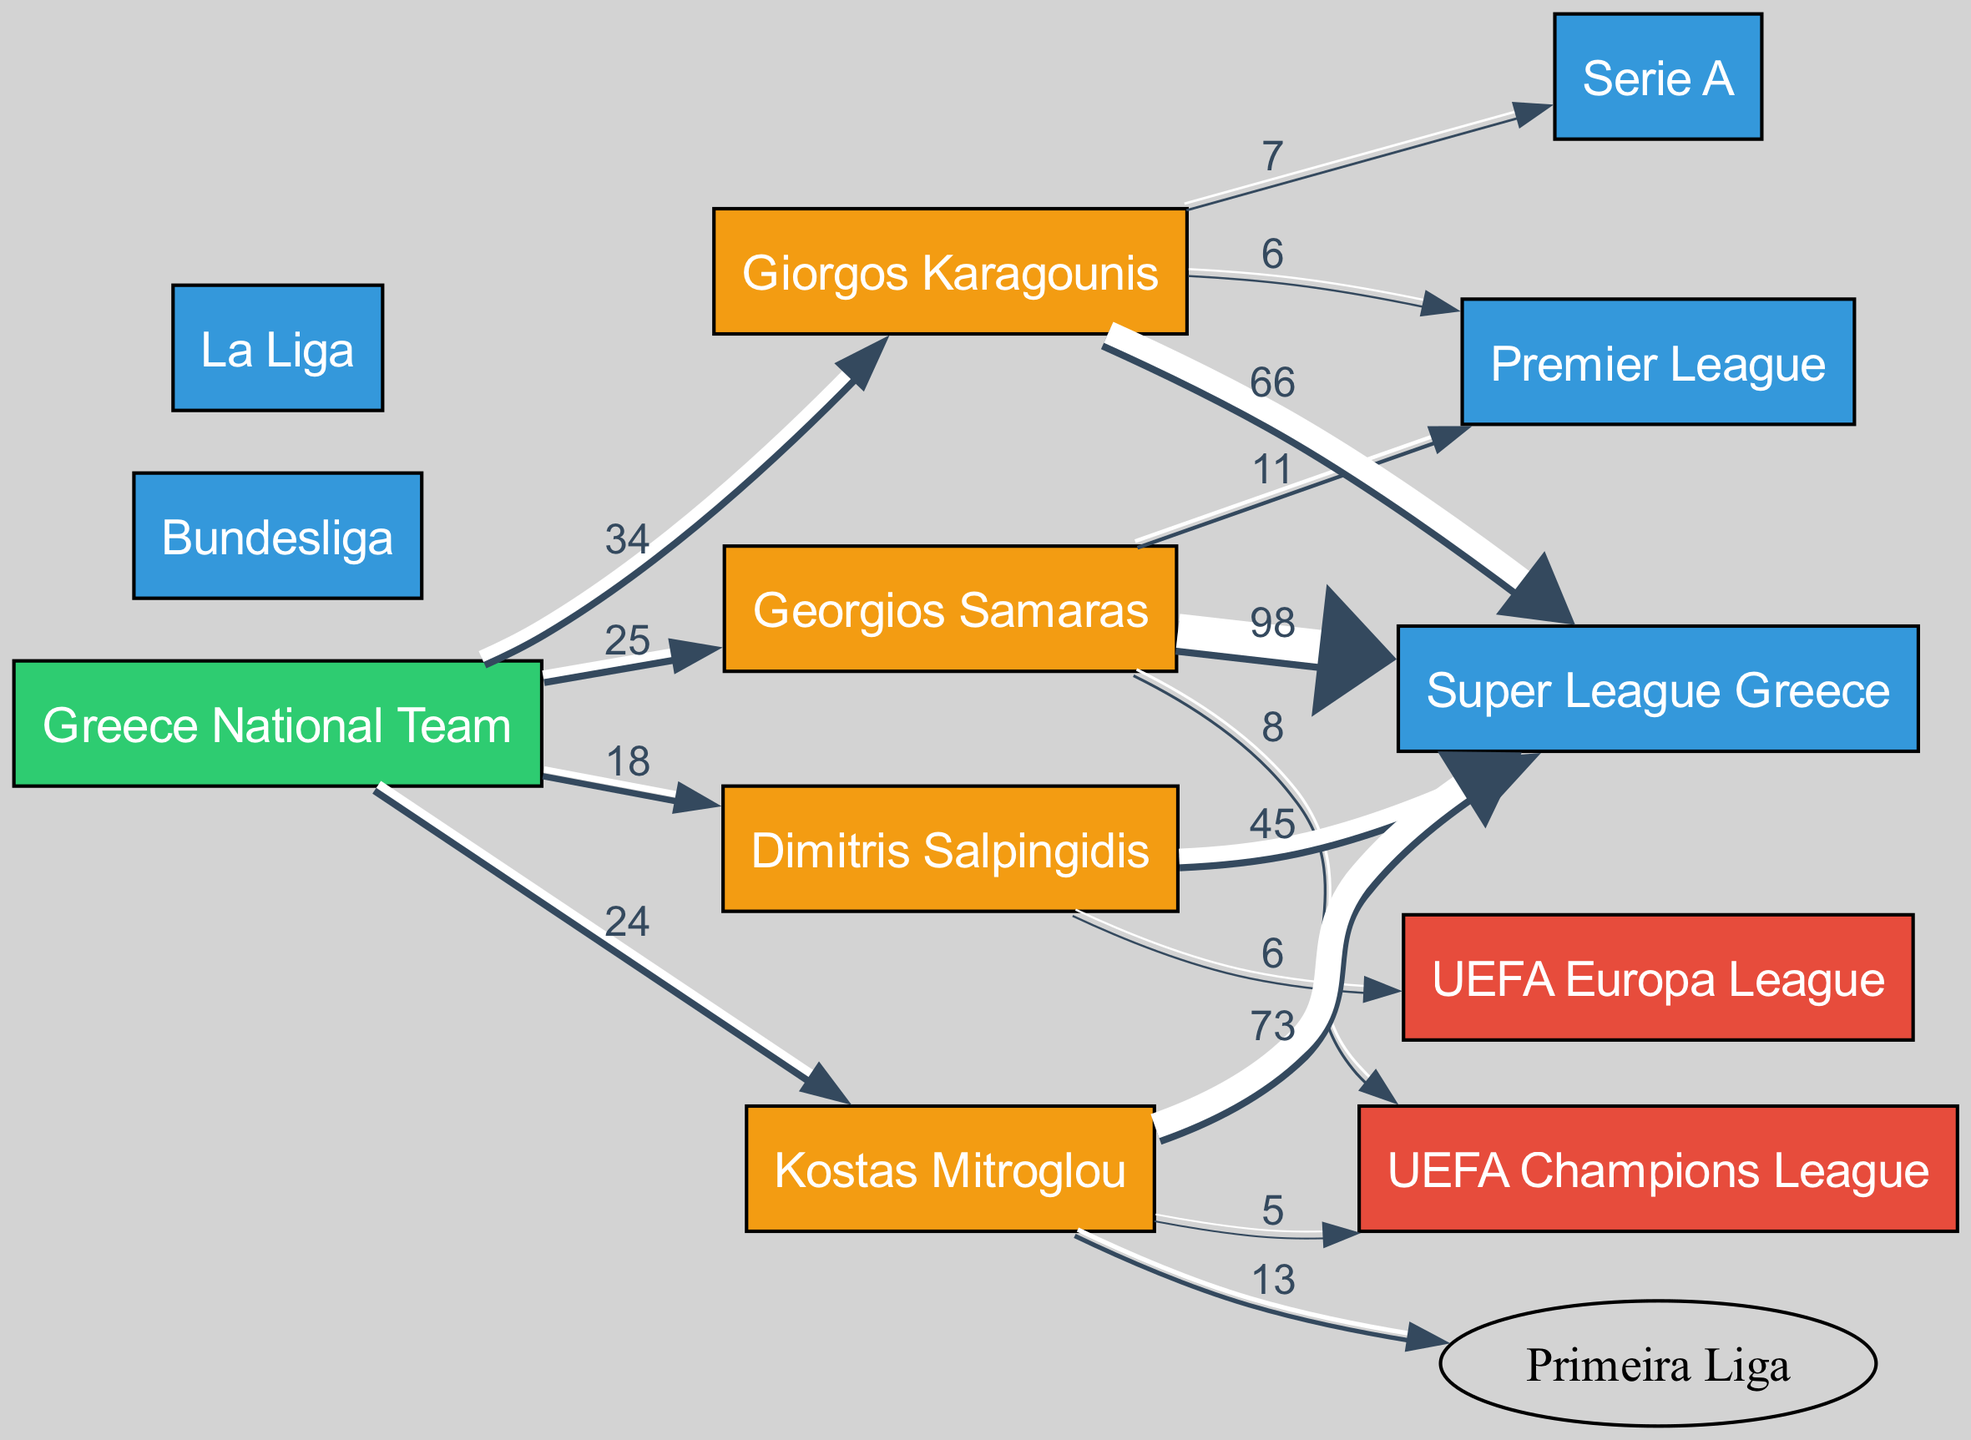What is the total number of goals scored by Georgios Samaras in the Super League Greece? The diagram shows a direct link from Georgios Samaras to the Super League Greece with a value of 98. This value represents the total number of goals he scored in that league.
Answer: 98 Which player scored the most goals in the Super League Greece? By observing the links from all players to the Super League Greece, Georgios Samaras has the highest value of 98, compared to the others such as Kostas Mitroglou with 73, Giorgos Karagounis with 66, and Dimitris Salpingidis with 45.
Answer: Georgios Samaras How many goals did Kostas Mitroglou score in total across all competitions? To find the total goals, we need to sum the values from all links connected to Kostas Mitroglou: Super League Greece (73) + Primeira Liga (13) + UEFA Champions League (5) equals 91.
Answer: 91 What is the ratio of goals scored by Dimitris Salpingidis in the Super League Greece to those scored in the UEFA Europa League? Dimitris Salpingidis scored 45 goals in the Super League Greece and 6 in the UEFA Europa League. The ratio is 45:6, which simplifies to 7.5:1.
Answer: 7.5:1 How many total goals did the Greece National Team score from Georgios Samaras and Giorgos Karagounis combined? For the Greece National Team, Georgios Samaras contributed 25 goals and Giorgos Karagounis contributed 34 goals. Adding these together gives 25 + 34 = 59.
Answer: 59 Which league had the highest representation of goals scored by the players? The highest goals are found in the Super League Greece from the players, with contributions from several players: Georgios Samaras (98), Kostas Mitroglou (73), Giorgos Karagounis (66), and Dimitris Salpingidis (45), totaling to 282 goals. This is more than any other league listed.
Answer: Super League Greece What is the total number of players represented in the diagram? The diagram contains a total of 4 individual players (Georgios Samaras, Dimitris Salpingidis, Kostas Mitroglou, and Giorgos Karagounis) shown in the nodes section.
Answer: 4 How many different leagues are represented in the diagram? Upon analyzing the nodes in the diagram, we can identify that there are 5 leagues listed: Super League Greece, Bundesliga, Serie A, La Liga, and Premier League.
Answer: 5 Which competition had the least number of goals contributed by any individual player? In the diagram, we see that the lowest contribution in the UEFA Europa League is from Dimitris Salpingidis with just 6 goals. Other competitions have higher contributions, making this the lowest.
Answer: UEFA Europa League 